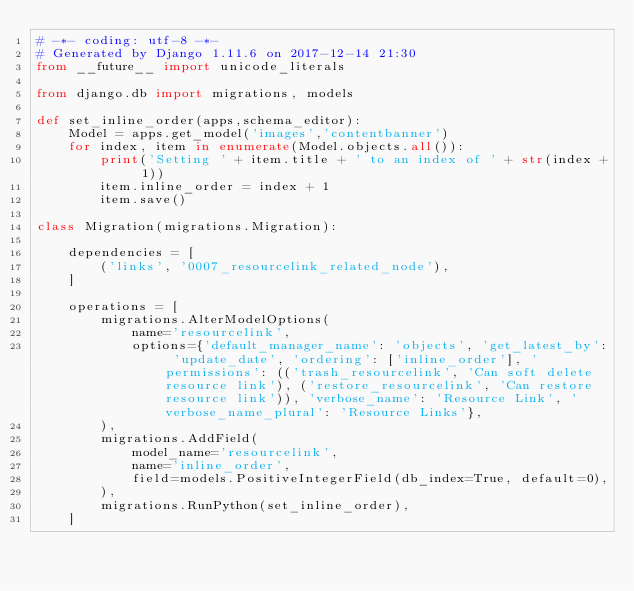Convert code to text. <code><loc_0><loc_0><loc_500><loc_500><_Python_># -*- coding: utf-8 -*-
# Generated by Django 1.11.6 on 2017-12-14 21:30
from __future__ import unicode_literals

from django.db import migrations, models

def set_inline_order(apps,schema_editor):
    Model = apps.get_model('images','contentbanner')
    for index, item in enumerate(Model.objects.all()):
        print('Setting ' + item.title + ' to an index of ' + str(index + 1))
        item.inline_order = index + 1
        item.save()

class Migration(migrations.Migration):

    dependencies = [
        ('links', '0007_resourcelink_related_node'),
    ]

    operations = [
        migrations.AlterModelOptions(
            name='resourcelink',
            options={'default_manager_name': 'objects', 'get_latest_by': 'update_date', 'ordering': ['inline_order'], 'permissions': (('trash_resourcelink', 'Can soft delete resource link'), ('restore_resourcelink', 'Can restore resource link')), 'verbose_name': 'Resource Link', 'verbose_name_plural': 'Resource Links'},
        ),
        migrations.AddField(
            model_name='resourcelink',
            name='inline_order',
            field=models.PositiveIntegerField(db_index=True, default=0),
        ),
        migrations.RunPython(set_inline_order),
    ]
</code> 